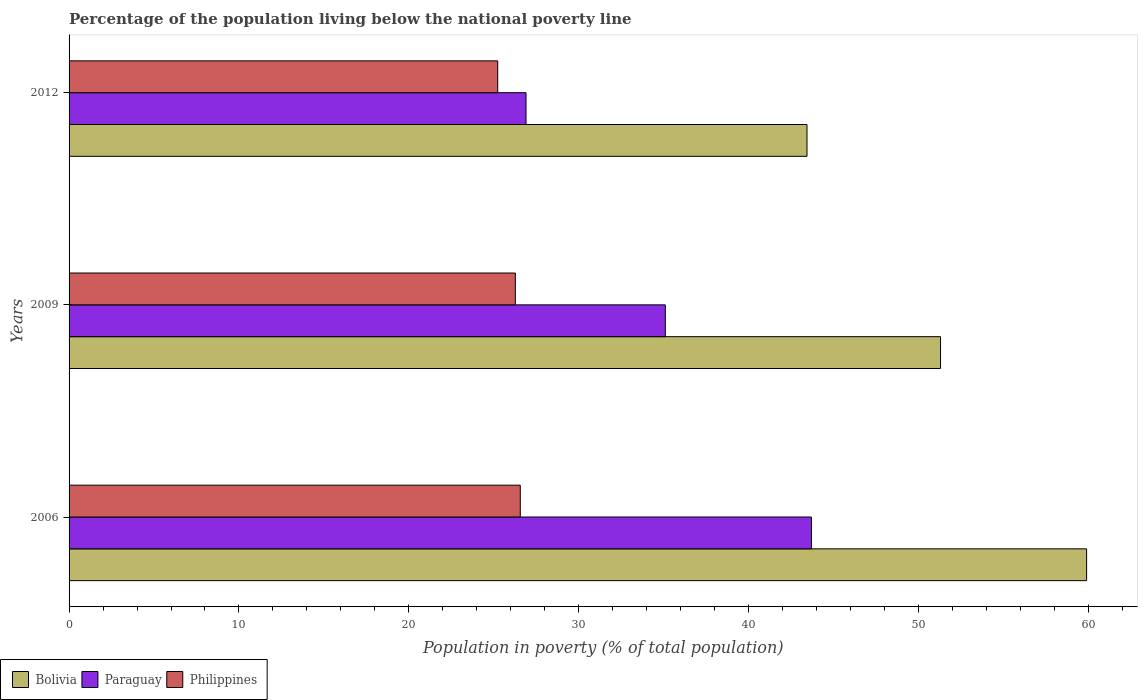How many different coloured bars are there?
Ensure brevity in your answer.  3. Are the number of bars per tick equal to the number of legend labels?
Your response must be concise. Yes. How many bars are there on the 3rd tick from the top?
Give a very brief answer. 3. What is the label of the 3rd group of bars from the top?
Ensure brevity in your answer.  2006. In how many cases, is the number of bars for a given year not equal to the number of legend labels?
Make the answer very short. 0. What is the percentage of the population living below the national poverty line in Bolivia in 2006?
Keep it short and to the point. 59.9. Across all years, what is the maximum percentage of the population living below the national poverty line in Philippines?
Offer a very short reply. 26.56. Across all years, what is the minimum percentage of the population living below the national poverty line in Paraguay?
Give a very brief answer. 26.9. In which year was the percentage of the population living below the national poverty line in Bolivia maximum?
Make the answer very short. 2006. In which year was the percentage of the population living below the national poverty line in Bolivia minimum?
Provide a short and direct response. 2012. What is the total percentage of the population living below the national poverty line in Philippines in the graph?
Provide a short and direct response. 78.07. What is the difference between the percentage of the population living below the national poverty line in Philippines in 2006 and that in 2012?
Offer a terse response. 1.33. What is the difference between the percentage of the population living below the national poverty line in Philippines in 2009 and the percentage of the population living below the national poverty line in Bolivia in 2012?
Provide a succinct answer. -17.17. What is the average percentage of the population living below the national poverty line in Paraguay per year?
Your answer should be compact. 35.23. In the year 2009, what is the difference between the percentage of the population living below the national poverty line in Philippines and percentage of the population living below the national poverty line in Paraguay?
Your answer should be very brief. -8.83. In how many years, is the percentage of the population living below the national poverty line in Paraguay greater than 34 %?
Offer a very short reply. 2. What is the ratio of the percentage of the population living below the national poverty line in Bolivia in 2009 to that in 2012?
Provide a short and direct response. 1.18. What is the difference between the highest and the second highest percentage of the population living below the national poverty line in Philippines?
Keep it short and to the point. 0.29. What is the difference between the highest and the lowest percentage of the population living below the national poverty line in Bolivia?
Keep it short and to the point. 16.46. In how many years, is the percentage of the population living below the national poverty line in Bolivia greater than the average percentage of the population living below the national poverty line in Bolivia taken over all years?
Your response must be concise. 1. How many bars are there?
Offer a very short reply. 9. Are all the bars in the graph horizontal?
Offer a terse response. Yes. How many years are there in the graph?
Give a very brief answer. 3. Does the graph contain any zero values?
Keep it short and to the point. No. Where does the legend appear in the graph?
Make the answer very short. Bottom left. How are the legend labels stacked?
Your answer should be compact. Horizontal. What is the title of the graph?
Your answer should be compact. Percentage of the population living below the national poverty line. What is the label or title of the X-axis?
Make the answer very short. Population in poverty (% of total population). What is the Population in poverty (% of total population) in Bolivia in 2006?
Provide a succinct answer. 59.9. What is the Population in poverty (% of total population) in Paraguay in 2006?
Your answer should be very brief. 43.7. What is the Population in poverty (% of total population) of Philippines in 2006?
Provide a succinct answer. 26.56. What is the Population in poverty (% of total population) in Bolivia in 2009?
Offer a terse response. 51.3. What is the Population in poverty (% of total population) of Paraguay in 2009?
Give a very brief answer. 35.1. What is the Population in poverty (% of total population) of Philippines in 2009?
Ensure brevity in your answer.  26.27. What is the Population in poverty (% of total population) in Bolivia in 2012?
Provide a succinct answer. 43.44. What is the Population in poverty (% of total population) of Paraguay in 2012?
Give a very brief answer. 26.9. What is the Population in poverty (% of total population) of Philippines in 2012?
Offer a very short reply. 25.23. Across all years, what is the maximum Population in poverty (% of total population) in Bolivia?
Keep it short and to the point. 59.9. Across all years, what is the maximum Population in poverty (% of total population) in Paraguay?
Your response must be concise. 43.7. Across all years, what is the maximum Population in poverty (% of total population) of Philippines?
Make the answer very short. 26.56. Across all years, what is the minimum Population in poverty (% of total population) in Bolivia?
Your response must be concise. 43.44. Across all years, what is the minimum Population in poverty (% of total population) in Paraguay?
Offer a terse response. 26.9. Across all years, what is the minimum Population in poverty (% of total population) of Philippines?
Your response must be concise. 25.23. What is the total Population in poverty (% of total population) in Bolivia in the graph?
Ensure brevity in your answer.  154.64. What is the total Population in poverty (% of total population) in Paraguay in the graph?
Ensure brevity in your answer.  105.7. What is the total Population in poverty (% of total population) of Philippines in the graph?
Provide a short and direct response. 78.07. What is the difference between the Population in poverty (% of total population) of Paraguay in 2006 and that in 2009?
Keep it short and to the point. 8.6. What is the difference between the Population in poverty (% of total population) of Philippines in 2006 and that in 2009?
Your response must be concise. 0.29. What is the difference between the Population in poverty (% of total population) of Bolivia in 2006 and that in 2012?
Provide a succinct answer. 16.46. What is the difference between the Population in poverty (% of total population) in Paraguay in 2006 and that in 2012?
Ensure brevity in your answer.  16.8. What is the difference between the Population in poverty (% of total population) of Philippines in 2006 and that in 2012?
Ensure brevity in your answer.  1.33. What is the difference between the Population in poverty (% of total population) in Bolivia in 2009 and that in 2012?
Provide a succinct answer. 7.86. What is the difference between the Population in poverty (% of total population) in Paraguay in 2009 and that in 2012?
Give a very brief answer. 8.2. What is the difference between the Population in poverty (% of total population) of Philippines in 2009 and that in 2012?
Keep it short and to the point. 1.04. What is the difference between the Population in poverty (% of total population) in Bolivia in 2006 and the Population in poverty (% of total population) in Paraguay in 2009?
Your answer should be very brief. 24.8. What is the difference between the Population in poverty (% of total population) of Bolivia in 2006 and the Population in poverty (% of total population) of Philippines in 2009?
Make the answer very short. 33.63. What is the difference between the Population in poverty (% of total population) of Paraguay in 2006 and the Population in poverty (% of total population) of Philippines in 2009?
Give a very brief answer. 17.43. What is the difference between the Population in poverty (% of total population) of Bolivia in 2006 and the Population in poverty (% of total population) of Philippines in 2012?
Your answer should be very brief. 34.67. What is the difference between the Population in poverty (% of total population) in Paraguay in 2006 and the Population in poverty (% of total population) in Philippines in 2012?
Your response must be concise. 18.47. What is the difference between the Population in poverty (% of total population) in Bolivia in 2009 and the Population in poverty (% of total population) in Paraguay in 2012?
Keep it short and to the point. 24.4. What is the difference between the Population in poverty (% of total population) of Bolivia in 2009 and the Population in poverty (% of total population) of Philippines in 2012?
Your answer should be very brief. 26.07. What is the difference between the Population in poverty (% of total population) in Paraguay in 2009 and the Population in poverty (% of total population) in Philippines in 2012?
Make the answer very short. 9.87. What is the average Population in poverty (% of total population) in Bolivia per year?
Your response must be concise. 51.55. What is the average Population in poverty (% of total population) in Paraguay per year?
Your response must be concise. 35.23. What is the average Population in poverty (% of total population) in Philippines per year?
Your answer should be compact. 26.02. In the year 2006, what is the difference between the Population in poverty (% of total population) of Bolivia and Population in poverty (% of total population) of Philippines?
Provide a short and direct response. 33.34. In the year 2006, what is the difference between the Population in poverty (% of total population) in Paraguay and Population in poverty (% of total population) in Philippines?
Your response must be concise. 17.14. In the year 2009, what is the difference between the Population in poverty (% of total population) in Bolivia and Population in poverty (% of total population) in Paraguay?
Offer a very short reply. 16.2. In the year 2009, what is the difference between the Population in poverty (% of total population) of Bolivia and Population in poverty (% of total population) of Philippines?
Give a very brief answer. 25.03. In the year 2009, what is the difference between the Population in poverty (% of total population) in Paraguay and Population in poverty (% of total population) in Philippines?
Keep it short and to the point. 8.83. In the year 2012, what is the difference between the Population in poverty (% of total population) of Bolivia and Population in poverty (% of total population) of Paraguay?
Offer a very short reply. 16.54. In the year 2012, what is the difference between the Population in poverty (% of total population) of Bolivia and Population in poverty (% of total population) of Philippines?
Make the answer very short. 18.21. In the year 2012, what is the difference between the Population in poverty (% of total population) in Paraguay and Population in poverty (% of total population) in Philippines?
Give a very brief answer. 1.67. What is the ratio of the Population in poverty (% of total population) in Bolivia in 2006 to that in 2009?
Give a very brief answer. 1.17. What is the ratio of the Population in poverty (% of total population) of Paraguay in 2006 to that in 2009?
Offer a terse response. 1.25. What is the ratio of the Population in poverty (% of total population) in Philippines in 2006 to that in 2009?
Provide a short and direct response. 1.01. What is the ratio of the Population in poverty (% of total population) in Bolivia in 2006 to that in 2012?
Ensure brevity in your answer.  1.38. What is the ratio of the Population in poverty (% of total population) of Paraguay in 2006 to that in 2012?
Provide a short and direct response. 1.62. What is the ratio of the Population in poverty (% of total population) in Philippines in 2006 to that in 2012?
Give a very brief answer. 1.05. What is the ratio of the Population in poverty (% of total population) of Bolivia in 2009 to that in 2012?
Give a very brief answer. 1.18. What is the ratio of the Population in poverty (% of total population) in Paraguay in 2009 to that in 2012?
Your response must be concise. 1.3. What is the ratio of the Population in poverty (% of total population) of Philippines in 2009 to that in 2012?
Provide a succinct answer. 1.04. What is the difference between the highest and the second highest Population in poverty (% of total population) in Philippines?
Offer a very short reply. 0.29. What is the difference between the highest and the lowest Population in poverty (% of total population) in Bolivia?
Give a very brief answer. 16.46. What is the difference between the highest and the lowest Population in poverty (% of total population) of Philippines?
Make the answer very short. 1.33. 